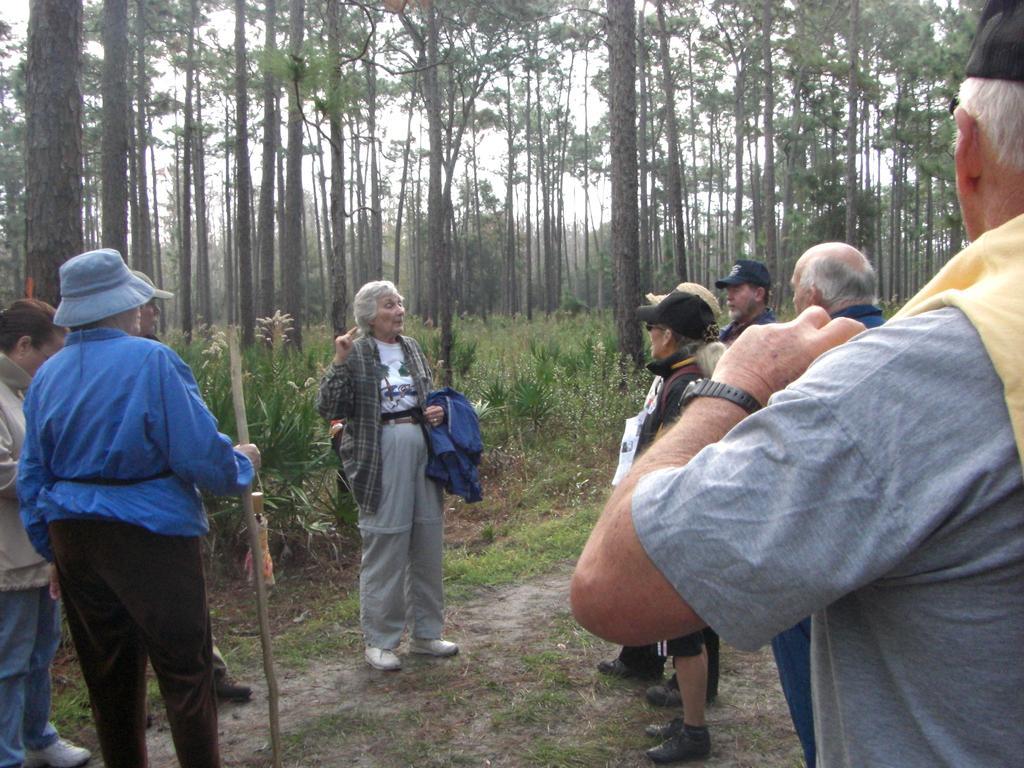Could you give a brief overview of what you see in this image? In this image few persons are standing on the land having some grass and plants on it. A person wearing a shirt is holding a cloth in his hand. A person wearing a blue jacket is holding a stick and an umbrella in his hand. Few persons are wearing a cap. Behind them there are few trees. 